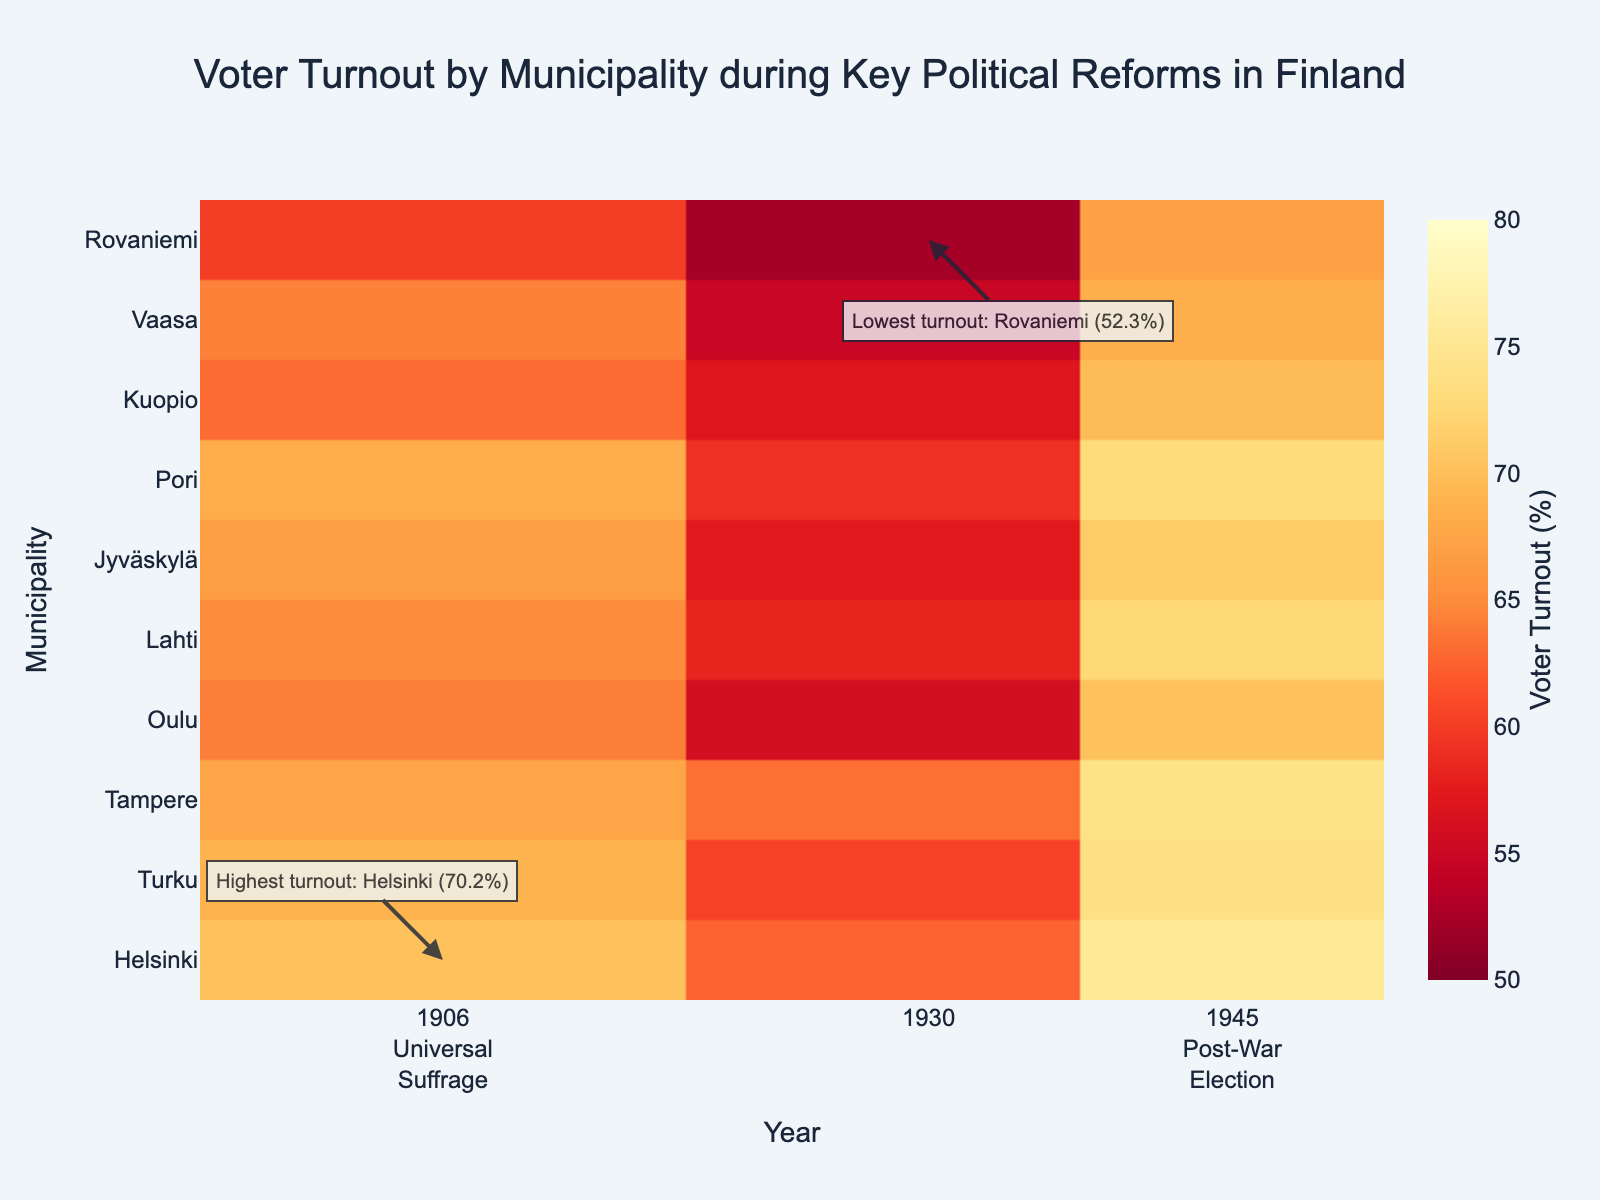What is the title of the figure? The title is often placed at the top of the figure and is intended to describe what the figure is about. In this case, it mentions both the subject (Voter Turnout) and the context (Key Political Reforms in Finland).
Answer: Voter Turnout by Municipality during Key Political Reforms in Finland Which municipality had the highest voter turnout in 1906? To answer this, locate the year 1906 on the x-axis, find the corresponding rows for each municipality, and identify the highest value.
Answer: Helsinki Which municipality had the lowest voter turnout in 1930? To find this, look at the year 1930 on the x-axis, go through each row to see the turnout percentages, and pick the lowest one.
Answer: Rovaniemi What is the color range used in the heatmap? The color range in a heatmap represents different value ranges. Look at the color bar, which is often located alongside the heatmap, to see the minimum and maximum values it represents.
Answer: 50% to 80% Compare voter turnout in Tampere between 1906 and 1945. Look at the row corresponding to Tampere and note the voter turnout figures for the years 1906 and 1945.
Answer: 67.5% in 1906, 74.1% in 1945 Which year had the largest number of municipalities with voter turnout above 70%? Count the number of municipalities in each year for which the voter turnout exceeds 70%. Compare these counts across the years 1906, 1930, and 1945.
Answer: 1945 What was the voter turnout in Lahti in 1930? Find the Lahti row and the column for the year 1930. Read the value where they intersect.
Answer: 58.2% By how much did voter turnout in Kuopio change from 1906 to 1945? Subtract the voter turnout percentage in 1906 from the percentage in 1945 for Kuopio. The answer is the difference in turnout rates.
Answer: 6.7% How many municipalities had voter turnout above 70% in 1945? In the 1945 column, count how many values exceed 70%.
Answer: 6 What significant political reforms are represented in the years shown on the x-axis? This information is typically noted near the x-axis, often with explanatory text.
Answer: 1906: Universal Suffrage, 1945: Post-War Election 